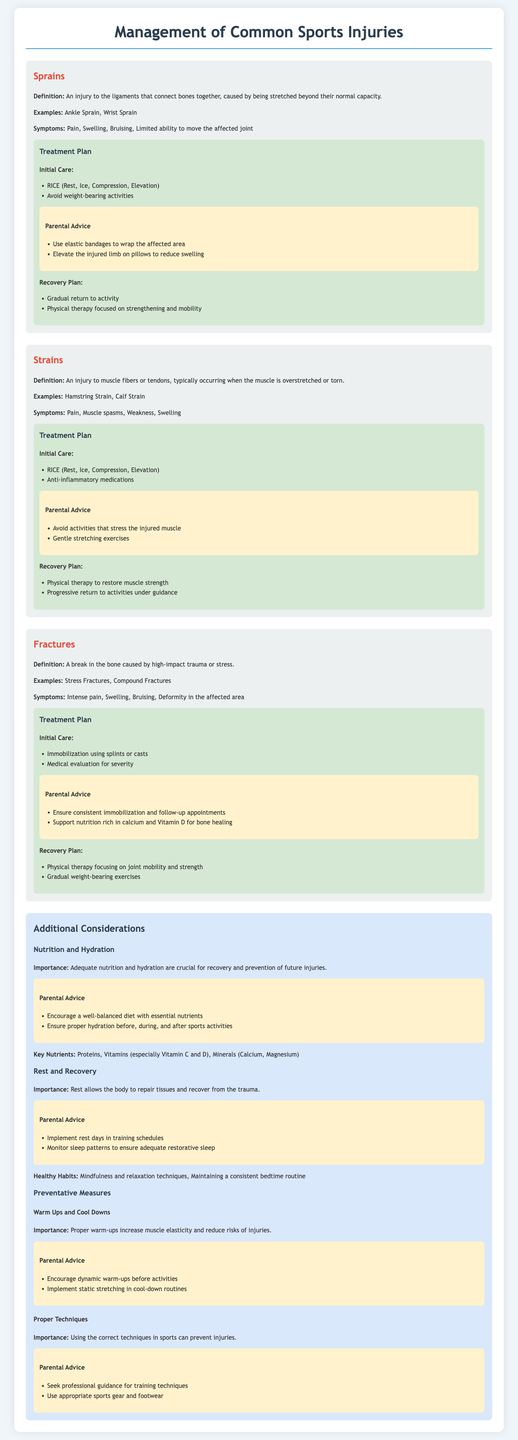What is a common symptom of a sprain? The common symptoms of a sprain include pain, swelling, bruising, and limited ability to move the affected joint, as stated in the "Sprains" section.
Answer: Pain What is one treatment for strains? The treatment plan for strains includes RICE (Rest, Ice, Compression, Elevation) and anti-inflammatory medications.
Answer: RICE Which type of injury involves a break in the bone? The document describes fractures as breaks in the bone caused by high-impact trauma or stress.
Answer: Fractures What advice is given regarding nutrition for recovery? The parental advice emphasizes ensuring nutrition rich in calcium and Vitamin D for bone healing during the recovery from fractures.
Answer: Calcium and Vitamin D What is one preventative measure mentioned in the document? One preventative measure involves encouraging dynamic warm-ups before activities to reduce the risks of injuries.
Answer: Dynamic warm-ups What is the primary focus of physical therapy for fractures? Physical therapy for fractures primarily focuses on joint mobility and strength during the recovery process.
Answer: Joint mobility and strength What does RICE stand for? RICE stands for Rest, Ice, Compression, Elevation, which is specified as the initial care for both sprains and strains.
Answer: Rest, Ice, Compression, Elevation During recovery from a strain, what type of exercises are recommended? The recovery plan for strains includes physical therapy to restore muscle strength, emphasizing progressive return to activities.
Answer: Progressive return to activities 